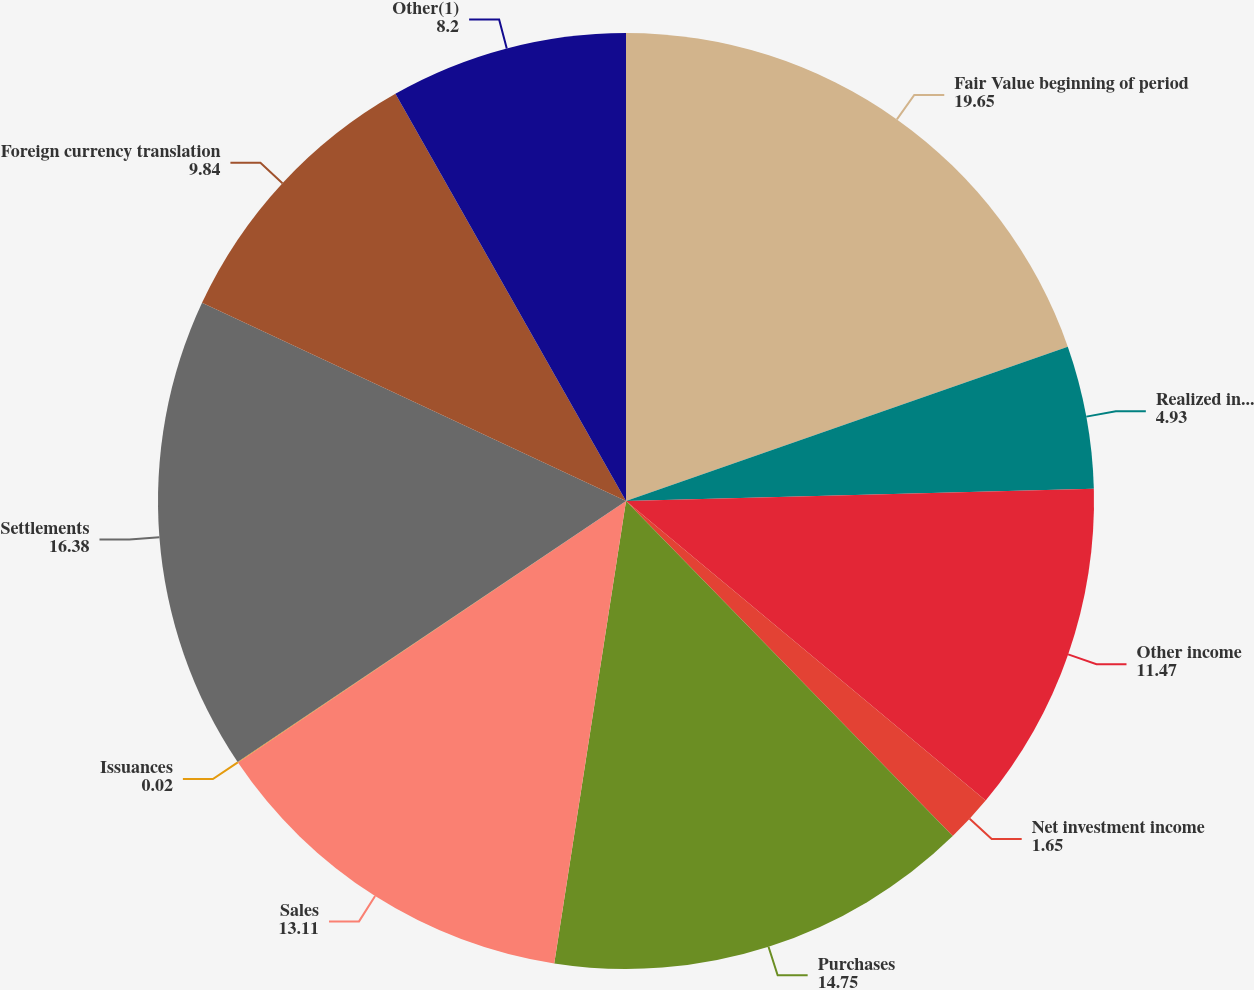Convert chart to OTSL. <chart><loc_0><loc_0><loc_500><loc_500><pie_chart><fcel>Fair Value beginning of period<fcel>Realized investment gains<fcel>Other income<fcel>Net investment income<fcel>Purchases<fcel>Sales<fcel>Issuances<fcel>Settlements<fcel>Foreign currency translation<fcel>Other(1)<nl><fcel>19.65%<fcel>4.93%<fcel>11.47%<fcel>1.65%<fcel>14.75%<fcel>13.11%<fcel>0.02%<fcel>16.38%<fcel>9.84%<fcel>8.2%<nl></chart> 